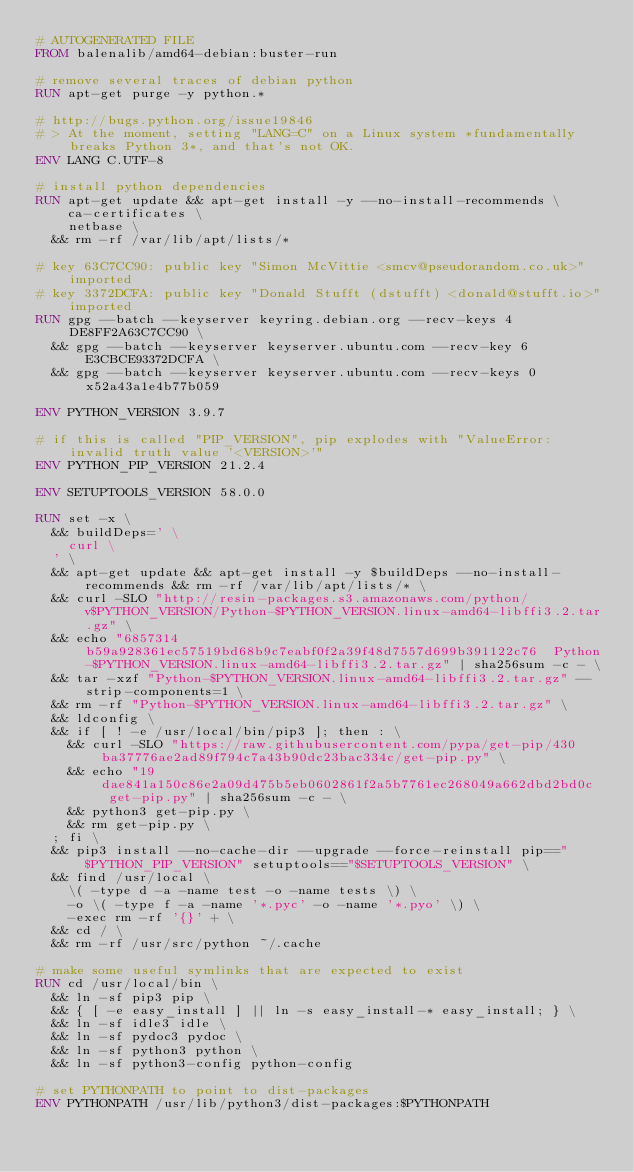Convert code to text. <code><loc_0><loc_0><loc_500><loc_500><_Dockerfile_># AUTOGENERATED FILE
FROM balenalib/amd64-debian:buster-run

# remove several traces of debian python
RUN apt-get purge -y python.*

# http://bugs.python.org/issue19846
# > At the moment, setting "LANG=C" on a Linux system *fundamentally breaks Python 3*, and that's not OK.
ENV LANG C.UTF-8

# install python dependencies
RUN apt-get update && apt-get install -y --no-install-recommends \
		ca-certificates \
		netbase \
	&& rm -rf /var/lib/apt/lists/*

# key 63C7CC90: public key "Simon McVittie <smcv@pseudorandom.co.uk>" imported
# key 3372DCFA: public key "Donald Stufft (dstufft) <donald@stufft.io>" imported
RUN gpg --batch --keyserver keyring.debian.org --recv-keys 4DE8FF2A63C7CC90 \
	&& gpg --batch --keyserver keyserver.ubuntu.com --recv-key 6E3CBCE93372DCFA \
	&& gpg --batch --keyserver keyserver.ubuntu.com --recv-keys 0x52a43a1e4b77b059

ENV PYTHON_VERSION 3.9.7

# if this is called "PIP_VERSION", pip explodes with "ValueError: invalid truth value '<VERSION>'"
ENV PYTHON_PIP_VERSION 21.2.4

ENV SETUPTOOLS_VERSION 58.0.0

RUN set -x \
	&& buildDeps=' \
		curl \
	' \
	&& apt-get update && apt-get install -y $buildDeps --no-install-recommends && rm -rf /var/lib/apt/lists/* \
	&& curl -SLO "http://resin-packages.s3.amazonaws.com/python/v$PYTHON_VERSION/Python-$PYTHON_VERSION.linux-amd64-libffi3.2.tar.gz" \
	&& echo "6857314b59a928361ec57519bd68b9c7eabf0f2a39f48d7557d699b391122c76  Python-$PYTHON_VERSION.linux-amd64-libffi3.2.tar.gz" | sha256sum -c - \
	&& tar -xzf "Python-$PYTHON_VERSION.linux-amd64-libffi3.2.tar.gz" --strip-components=1 \
	&& rm -rf "Python-$PYTHON_VERSION.linux-amd64-libffi3.2.tar.gz" \
	&& ldconfig \
	&& if [ ! -e /usr/local/bin/pip3 ]; then : \
		&& curl -SLO "https://raw.githubusercontent.com/pypa/get-pip/430ba37776ae2ad89f794c7a43b90dc23bac334c/get-pip.py" \
		&& echo "19dae841a150c86e2a09d475b5eb0602861f2a5b7761ec268049a662dbd2bd0c  get-pip.py" | sha256sum -c - \
		&& python3 get-pip.py \
		&& rm get-pip.py \
	; fi \
	&& pip3 install --no-cache-dir --upgrade --force-reinstall pip=="$PYTHON_PIP_VERSION" setuptools=="$SETUPTOOLS_VERSION" \
	&& find /usr/local \
		\( -type d -a -name test -o -name tests \) \
		-o \( -type f -a -name '*.pyc' -o -name '*.pyo' \) \
		-exec rm -rf '{}' + \
	&& cd / \
	&& rm -rf /usr/src/python ~/.cache

# make some useful symlinks that are expected to exist
RUN cd /usr/local/bin \
	&& ln -sf pip3 pip \
	&& { [ -e easy_install ] || ln -s easy_install-* easy_install; } \
	&& ln -sf idle3 idle \
	&& ln -sf pydoc3 pydoc \
	&& ln -sf python3 python \
	&& ln -sf python3-config python-config

# set PYTHONPATH to point to dist-packages
ENV PYTHONPATH /usr/lib/python3/dist-packages:$PYTHONPATH
</code> 